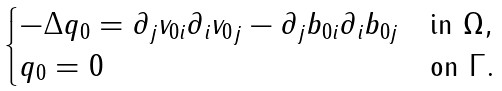Convert formula to latex. <formula><loc_0><loc_0><loc_500><loc_500>\begin{cases} - \Delta q _ { 0 } = \partial _ { j } v _ { 0 i } \partial _ { i } { v _ { 0 } } _ { j } - \partial _ { j } b _ { 0 i } \partial _ { i } b _ { 0 j } & \text {in } \Omega , \\ q _ { 0 } = 0 & \text {on } \Gamma . \end{cases}</formula> 